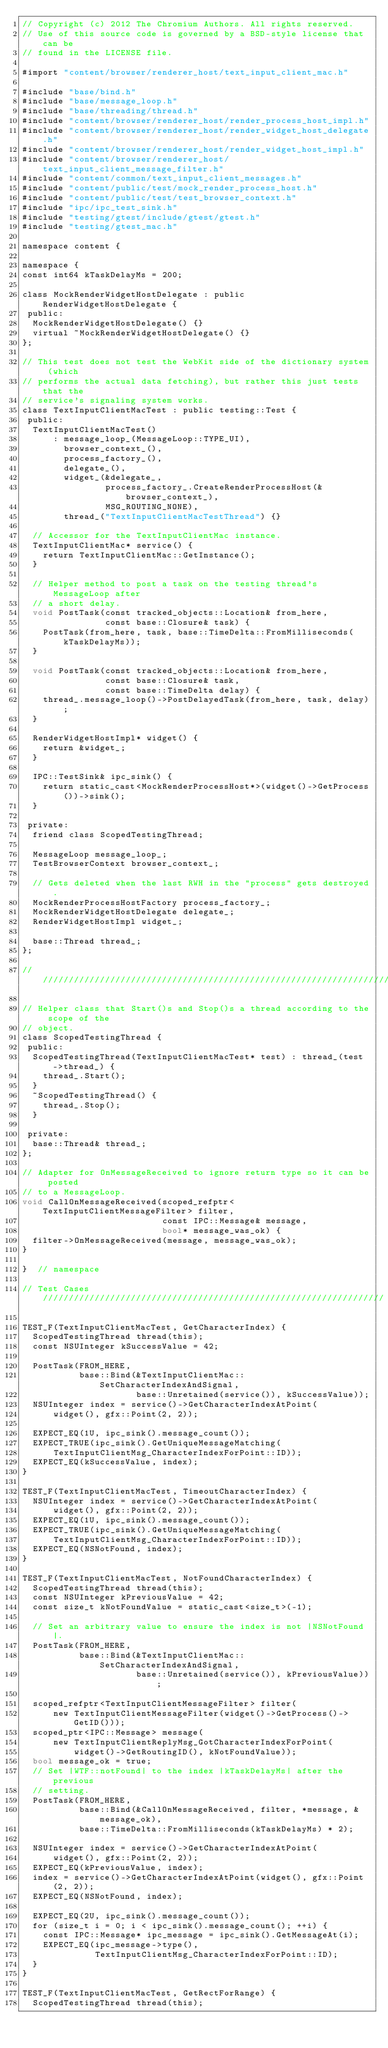Convert code to text. <code><loc_0><loc_0><loc_500><loc_500><_ObjectiveC_>// Copyright (c) 2012 The Chromium Authors. All rights reserved.
// Use of this source code is governed by a BSD-style license that can be
// found in the LICENSE file.

#import "content/browser/renderer_host/text_input_client_mac.h"

#include "base/bind.h"
#include "base/message_loop.h"
#include "base/threading/thread.h"
#include "content/browser/renderer_host/render_process_host_impl.h"
#include "content/browser/renderer_host/render_widget_host_delegate.h"
#include "content/browser/renderer_host/render_widget_host_impl.h"
#include "content/browser/renderer_host/text_input_client_message_filter.h"
#include "content/common/text_input_client_messages.h"
#include "content/public/test/mock_render_process_host.h"
#include "content/public/test/test_browser_context.h"
#include "ipc/ipc_test_sink.h"
#include "testing/gtest/include/gtest/gtest.h"
#include "testing/gtest_mac.h"

namespace content {

namespace {
const int64 kTaskDelayMs = 200;

class MockRenderWidgetHostDelegate : public RenderWidgetHostDelegate {
 public:
  MockRenderWidgetHostDelegate() {}
  virtual ~MockRenderWidgetHostDelegate() {}
};

// This test does not test the WebKit side of the dictionary system (which
// performs the actual data fetching), but rather this just tests that the
// service's signaling system works.
class TextInputClientMacTest : public testing::Test {
 public:
  TextInputClientMacTest()
      : message_loop_(MessageLoop::TYPE_UI),
        browser_context_(),
        process_factory_(),
        delegate_(),
        widget_(&delegate_,
                process_factory_.CreateRenderProcessHost(&browser_context_),
                MSG_ROUTING_NONE),
        thread_("TextInputClientMacTestThread") {}

  // Accessor for the TextInputClientMac instance.
  TextInputClientMac* service() {
    return TextInputClientMac::GetInstance();
  }

  // Helper method to post a task on the testing thread's MessageLoop after
  // a short delay.
  void PostTask(const tracked_objects::Location& from_here,
                const base::Closure& task) {
    PostTask(from_here, task, base::TimeDelta::FromMilliseconds(kTaskDelayMs));
  }

  void PostTask(const tracked_objects::Location& from_here,
                const base::Closure& task,
                const base::TimeDelta delay) {
    thread_.message_loop()->PostDelayedTask(from_here, task, delay);
  }

  RenderWidgetHostImpl* widget() {
    return &widget_;
  }

  IPC::TestSink& ipc_sink() {
    return static_cast<MockRenderProcessHost*>(widget()->GetProcess())->sink();
  }

 private:
  friend class ScopedTestingThread;

  MessageLoop message_loop_;
  TestBrowserContext browser_context_;

  // Gets deleted when the last RWH in the "process" gets destroyed.
  MockRenderProcessHostFactory process_factory_;
  MockRenderWidgetHostDelegate delegate_;
  RenderWidgetHostImpl widget_;

  base::Thread thread_;
};

////////////////////////////////////////////////////////////////////////////////

// Helper class that Start()s and Stop()s a thread according to the scope of the
// object.
class ScopedTestingThread {
 public:
  ScopedTestingThread(TextInputClientMacTest* test) : thread_(test->thread_) {
    thread_.Start();
  }
  ~ScopedTestingThread() {
    thread_.Stop();
  }

 private:
  base::Thread& thread_;
};

// Adapter for OnMessageReceived to ignore return type so it can be posted
// to a MessageLoop.
void CallOnMessageReceived(scoped_refptr<TextInputClientMessageFilter> filter,
                           const IPC::Message& message,
                           bool* message_was_ok) {
  filter->OnMessageReceived(message, message_was_ok);
}

}  // namespace

// Test Cases //////////////////////////////////////////////////////////////////

TEST_F(TextInputClientMacTest, GetCharacterIndex) {
  ScopedTestingThread thread(this);
  const NSUInteger kSuccessValue = 42;

  PostTask(FROM_HERE,
           base::Bind(&TextInputClientMac::SetCharacterIndexAndSignal,
                      base::Unretained(service()), kSuccessValue));
  NSUInteger index = service()->GetCharacterIndexAtPoint(
      widget(), gfx::Point(2, 2));

  EXPECT_EQ(1U, ipc_sink().message_count());
  EXPECT_TRUE(ipc_sink().GetUniqueMessageMatching(
      TextInputClientMsg_CharacterIndexForPoint::ID));
  EXPECT_EQ(kSuccessValue, index);
}

TEST_F(TextInputClientMacTest, TimeoutCharacterIndex) {
  NSUInteger index = service()->GetCharacterIndexAtPoint(
      widget(), gfx::Point(2, 2));
  EXPECT_EQ(1U, ipc_sink().message_count());
  EXPECT_TRUE(ipc_sink().GetUniqueMessageMatching(
      TextInputClientMsg_CharacterIndexForPoint::ID));
  EXPECT_EQ(NSNotFound, index);
}

TEST_F(TextInputClientMacTest, NotFoundCharacterIndex) {
  ScopedTestingThread thread(this);
  const NSUInteger kPreviousValue = 42;
  const size_t kNotFoundValue = static_cast<size_t>(-1);

  // Set an arbitrary value to ensure the index is not |NSNotFound|.
  PostTask(FROM_HERE,
           base::Bind(&TextInputClientMac::SetCharacterIndexAndSignal,
                      base::Unretained(service()), kPreviousValue));

  scoped_refptr<TextInputClientMessageFilter> filter(
      new TextInputClientMessageFilter(widget()->GetProcess()->GetID()));
  scoped_ptr<IPC::Message> message(
      new TextInputClientReplyMsg_GotCharacterIndexForPoint(
          widget()->GetRoutingID(), kNotFoundValue));
  bool message_ok = true;
  // Set |WTF::notFound| to the index |kTaskDelayMs| after the previous
  // setting.
  PostTask(FROM_HERE,
           base::Bind(&CallOnMessageReceived, filter, *message, &message_ok),
           base::TimeDelta::FromMilliseconds(kTaskDelayMs) * 2);

  NSUInteger index = service()->GetCharacterIndexAtPoint(
      widget(), gfx::Point(2, 2));
  EXPECT_EQ(kPreviousValue, index);
  index = service()->GetCharacterIndexAtPoint(widget(), gfx::Point(2, 2));
  EXPECT_EQ(NSNotFound, index);

  EXPECT_EQ(2U, ipc_sink().message_count());
  for (size_t i = 0; i < ipc_sink().message_count(); ++i) {
    const IPC::Message* ipc_message = ipc_sink().GetMessageAt(i);
    EXPECT_EQ(ipc_message->type(),
              TextInputClientMsg_CharacterIndexForPoint::ID);
  }
}

TEST_F(TextInputClientMacTest, GetRectForRange) {
  ScopedTestingThread thread(this);</code> 